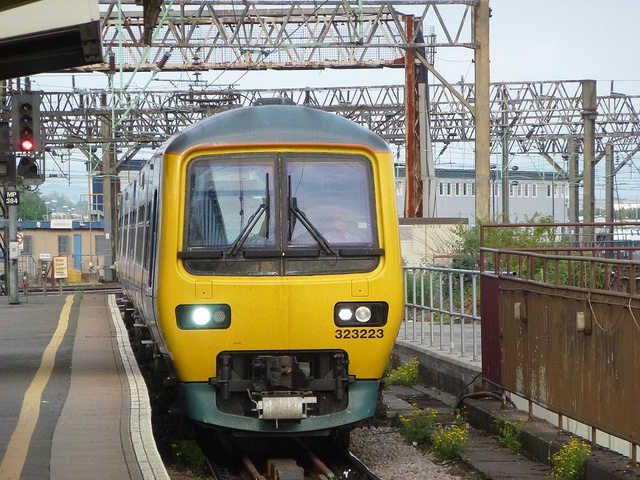Describe the objects in this image and their specific colors. I can see train in black, gray, gold, and darkgray tones, traffic light in black, maroon, gray, and white tones, and traffic light in black, gray, and navy tones in this image. 